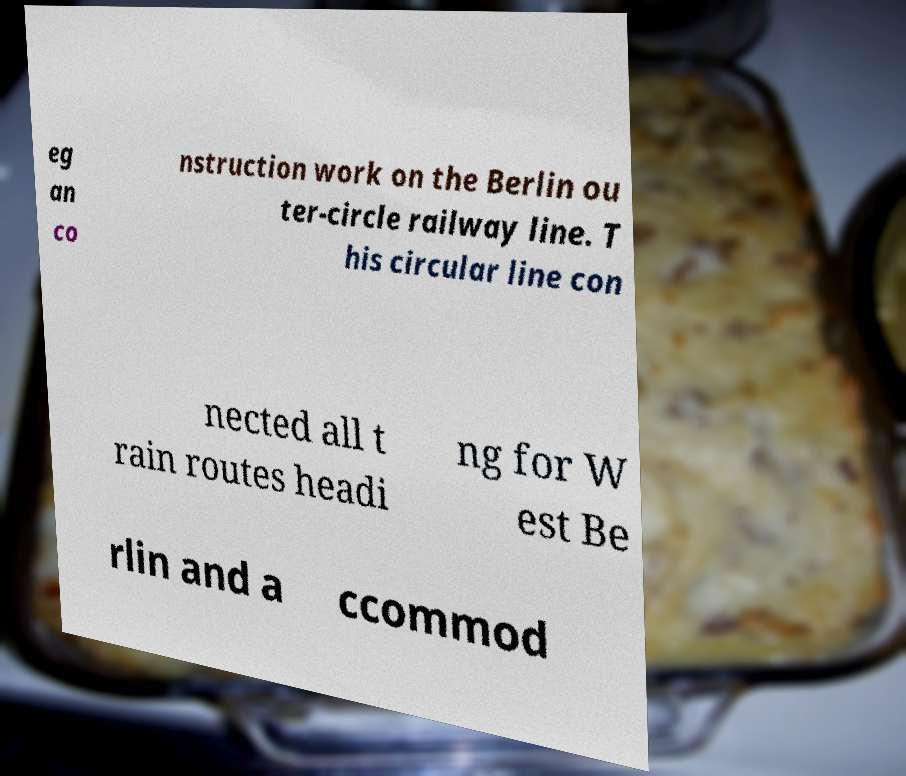Please read and relay the text visible in this image. What does it say? eg an co nstruction work on the Berlin ou ter-circle railway line. T his circular line con nected all t rain routes headi ng for W est Be rlin and a ccommod 